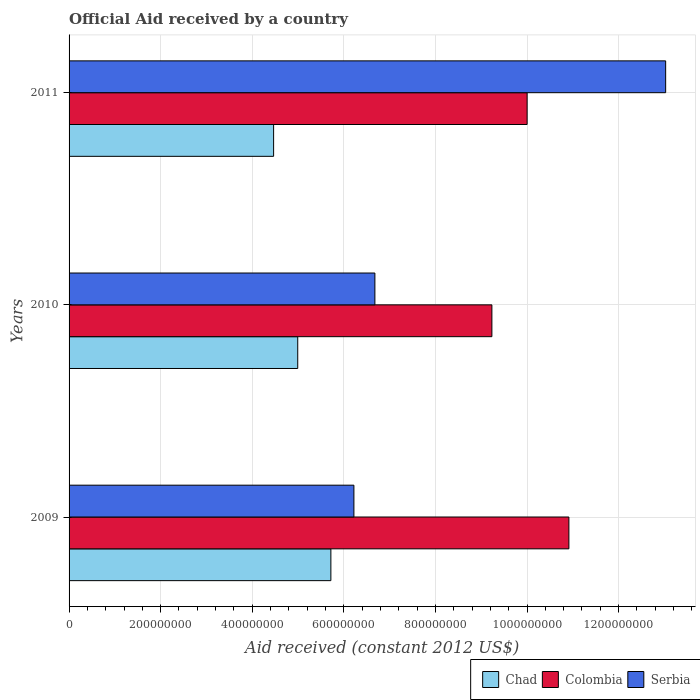How many bars are there on the 2nd tick from the top?
Offer a very short reply. 3. How many bars are there on the 2nd tick from the bottom?
Keep it short and to the point. 3. In how many cases, is the number of bars for a given year not equal to the number of legend labels?
Offer a terse response. 0. What is the net official aid received in Colombia in 2009?
Provide a short and direct response. 1.09e+09. Across all years, what is the maximum net official aid received in Colombia?
Provide a short and direct response. 1.09e+09. Across all years, what is the minimum net official aid received in Serbia?
Provide a short and direct response. 6.22e+08. In which year was the net official aid received in Serbia minimum?
Ensure brevity in your answer.  2009. What is the total net official aid received in Chad in the graph?
Make the answer very short. 1.52e+09. What is the difference between the net official aid received in Chad in 2009 and that in 2011?
Provide a short and direct response. 1.25e+08. What is the difference between the net official aid received in Chad in 2010 and the net official aid received in Serbia in 2009?
Make the answer very short. -1.23e+08. What is the average net official aid received in Colombia per year?
Make the answer very short. 1.01e+09. In the year 2011, what is the difference between the net official aid received in Serbia and net official aid received in Colombia?
Give a very brief answer. 3.03e+08. In how many years, is the net official aid received in Serbia greater than 1080000000 US$?
Keep it short and to the point. 1. What is the ratio of the net official aid received in Serbia in 2009 to that in 2011?
Your answer should be compact. 0.48. Is the net official aid received in Serbia in 2009 less than that in 2010?
Provide a short and direct response. Yes. Is the difference between the net official aid received in Serbia in 2009 and 2011 greater than the difference between the net official aid received in Colombia in 2009 and 2011?
Your answer should be very brief. No. What is the difference between the highest and the second highest net official aid received in Chad?
Ensure brevity in your answer.  7.24e+07. What is the difference between the highest and the lowest net official aid received in Colombia?
Your response must be concise. 1.68e+08. In how many years, is the net official aid received in Chad greater than the average net official aid received in Chad taken over all years?
Provide a short and direct response. 1. What does the 1st bar from the top in 2011 represents?
Your response must be concise. Serbia. What does the 3rd bar from the bottom in 2010 represents?
Make the answer very short. Serbia. How many bars are there?
Ensure brevity in your answer.  9. How many years are there in the graph?
Keep it short and to the point. 3. What is the difference between two consecutive major ticks on the X-axis?
Your response must be concise. 2.00e+08. Are the values on the major ticks of X-axis written in scientific E-notation?
Keep it short and to the point. No. Does the graph contain any zero values?
Offer a terse response. No. Does the graph contain grids?
Ensure brevity in your answer.  Yes. How are the legend labels stacked?
Your answer should be very brief. Horizontal. What is the title of the graph?
Give a very brief answer. Official Aid received by a country. Does "Timor-Leste" appear as one of the legend labels in the graph?
Make the answer very short. No. What is the label or title of the X-axis?
Your answer should be very brief. Aid received (constant 2012 US$). What is the Aid received (constant 2012 US$) in Chad in 2009?
Keep it short and to the point. 5.72e+08. What is the Aid received (constant 2012 US$) in Colombia in 2009?
Offer a terse response. 1.09e+09. What is the Aid received (constant 2012 US$) of Serbia in 2009?
Give a very brief answer. 6.22e+08. What is the Aid received (constant 2012 US$) in Chad in 2010?
Offer a very short reply. 4.99e+08. What is the Aid received (constant 2012 US$) in Colombia in 2010?
Your answer should be compact. 9.23e+08. What is the Aid received (constant 2012 US$) of Serbia in 2010?
Your answer should be very brief. 6.68e+08. What is the Aid received (constant 2012 US$) of Chad in 2011?
Your response must be concise. 4.47e+08. What is the Aid received (constant 2012 US$) of Colombia in 2011?
Your answer should be compact. 1.00e+09. What is the Aid received (constant 2012 US$) in Serbia in 2011?
Provide a short and direct response. 1.30e+09. Across all years, what is the maximum Aid received (constant 2012 US$) in Chad?
Your response must be concise. 5.72e+08. Across all years, what is the maximum Aid received (constant 2012 US$) of Colombia?
Keep it short and to the point. 1.09e+09. Across all years, what is the maximum Aid received (constant 2012 US$) in Serbia?
Offer a very short reply. 1.30e+09. Across all years, what is the minimum Aid received (constant 2012 US$) in Chad?
Give a very brief answer. 4.47e+08. Across all years, what is the minimum Aid received (constant 2012 US$) in Colombia?
Provide a short and direct response. 9.23e+08. Across all years, what is the minimum Aid received (constant 2012 US$) in Serbia?
Ensure brevity in your answer.  6.22e+08. What is the total Aid received (constant 2012 US$) in Chad in the graph?
Offer a very short reply. 1.52e+09. What is the total Aid received (constant 2012 US$) in Colombia in the graph?
Your answer should be compact. 3.02e+09. What is the total Aid received (constant 2012 US$) in Serbia in the graph?
Offer a very short reply. 2.59e+09. What is the difference between the Aid received (constant 2012 US$) of Chad in 2009 and that in 2010?
Give a very brief answer. 7.24e+07. What is the difference between the Aid received (constant 2012 US$) in Colombia in 2009 and that in 2010?
Provide a short and direct response. 1.68e+08. What is the difference between the Aid received (constant 2012 US$) in Serbia in 2009 and that in 2010?
Make the answer very short. -4.58e+07. What is the difference between the Aid received (constant 2012 US$) of Chad in 2009 and that in 2011?
Ensure brevity in your answer.  1.25e+08. What is the difference between the Aid received (constant 2012 US$) of Colombia in 2009 and that in 2011?
Your response must be concise. 9.12e+07. What is the difference between the Aid received (constant 2012 US$) of Serbia in 2009 and that in 2011?
Your response must be concise. -6.81e+08. What is the difference between the Aid received (constant 2012 US$) of Chad in 2010 and that in 2011?
Ensure brevity in your answer.  5.27e+07. What is the difference between the Aid received (constant 2012 US$) in Colombia in 2010 and that in 2011?
Give a very brief answer. -7.69e+07. What is the difference between the Aid received (constant 2012 US$) in Serbia in 2010 and that in 2011?
Give a very brief answer. -6.35e+08. What is the difference between the Aid received (constant 2012 US$) in Chad in 2009 and the Aid received (constant 2012 US$) in Colombia in 2010?
Give a very brief answer. -3.52e+08. What is the difference between the Aid received (constant 2012 US$) in Chad in 2009 and the Aid received (constant 2012 US$) in Serbia in 2010?
Provide a short and direct response. -9.61e+07. What is the difference between the Aid received (constant 2012 US$) in Colombia in 2009 and the Aid received (constant 2012 US$) in Serbia in 2010?
Ensure brevity in your answer.  4.24e+08. What is the difference between the Aid received (constant 2012 US$) in Chad in 2009 and the Aid received (constant 2012 US$) in Colombia in 2011?
Your answer should be compact. -4.29e+08. What is the difference between the Aid received (constant 2012 US$) in Chad in 2009 and the Aid received (constant 2012 US$) in Serbia in 2011?
Ensure brevity in your answer.  -7.31e+08. What is the difference between the Aid received (constant 2012 US$) of Colombia in 2009 and the Aid received (constant 2012 US$) of Serbia in 2011?
Give a very brief answer. -2.11e+08. What is the difference between the Aid received (constant 2012 US$) in Chad in 2010 and the Aid received (constant 2012 US$) in Colombia in 2011?
Offer a very short reply. -5.01e+08. What is the difference between the Aid received (constant 2012 US$) in Chad in 2010 and the Aid received (constant 2012 US$) in Serbia in 2011?
Ensure brevity in your answer.  -8.03e+08. What is the difference between the Aid received (constant 2012 US$) in Colombia in 2010 and the Aid received (constant 2012 US$) in Serbia in 2011?
Keep it short and to the point. -3.79e+08. What is the average Aid received (constant 2012 US$) in Chad per year?
Your answer should be compact. 5.06e+08. What is the average Aid received (constant 2012 US$) in Colombia per year?
Your answer should be very brief. 1.01e+09. What is the average Aid received (constant 2012 US$) of Serbia per year?
Your answer should be very brief. 8.64e+08. In the year 2009, what is the difference between the Aid received (constant 2012 US$) in Chad and Aid received (constant 2012 US$) in Colombia?
Your response must be concise. -5.20e+08. In the year 2009, what is the difference between the Aid received (constant 2012 US$) of Chad and Aid received (constant 2012 US$) of Serbia?
Make the answer very short. -5.03e+07. In the year 2009, what is the difference between the Aid received (constant 2012 US$) of Colombia and Aid received (constant 2012 US$) of Serbia?
Your answer should be very brief. 4.69e+08. In the year 2010, what is the difference between the Aid received (constant 2012 US$) of Chad and Aid received (constant 2012 US$) of Colombia?
Provide a short and direct response. -4.24e+08. In the year 2010, what is the difference between the Aid received (constant 2012 US$) in Chad and Aid received (constant 2012 US$) in Serbia?
Offer a very short reply. -1.68e+08. In the year 2010, what is the difference between the Aid received (constant 2012 US$) of Colombia and Aid received (constant 2012 US$) of Serbia?
Provide a succinct answer. 2.56e+08. In the year 2011, what is the difference between the Aid received (constant 2012 US$) in Chad and Aid received (constant 2012 US$) in Colombia?
Offer a very short reply. -5.54e+08. In the year 2011, what is the difference between the Aid received (constant 2012 US$) of Chad and Aid received (constant 2012 US$) of Serbia?
Your answer should be compact. -8.56e+08. In the year 2011, what is the difference between the Aid received (constant 2012 US$) in Colombia and Aid received (constant 2012 US$) in Serbia?
Ensure brevity in your answer.  -3.03e+08. What is the ratio of the Aid received (constant 2012 US$) of Chad in 2009 to that in 2010?
Provide a succinct answer. 1.14. What is the ratio of the Aid received (constant 2012 US$) in Colombia in 2009 to that in 2010?
Ensure brevity in your answer.  1.18. What is the ratio of the Aid received (constant 2012 US$) of Serbia in 2009 to that in 2010?
Provide a short and direct response. 0.93. What is the ratio of the Aid received (constant 2012 US$) of Chad in 2009 to that in 2011?
Give a very brief answer. 1.28. What is the ratio of the Aid received (constant 2012 US$) of Colombia in 2009 to that in 2011?
Your answer should be compact. 1.09. What is the ratio of the Aid received (constant 2012 US$) of Serbia in 2009 to that in 2011?
Your answer should be very brief. 0.48. What is the ratio of the Aid received (constant 2012 US$) in Chad in 2010 to that in 2011?
Your answer should be very brief. 1.12. What is the ratio of the Aid received (constant 2012 US$) in Serbia in 2010 to that in 2011?
Make the answer very short. 0.51. What is the difference between the highest and the second highest Aid received (constant 2012 US$) of Chad?
Give a very brief answer. 7.24e+07. What is the difference between the highest and the second highest Aid received (constant 2012 US$) of Colombia?
Offer a terse response. 9.12e+07. What is the difference between the highest and the second highest Aid received (constant 2012 US$) in Serbia?
Make the answer very short. 6.35e+08. What is the difference between the highest and the lowest Aid received (constant 2012 US$) of Chad?
Give a very brief answer. 1.25e+08. What is the difference between the highest and the lowest Aid received (constant 2012 US$) of Colombia?
Provide a short and direct response. 1.68e+08. What is the difference between the highest and the lowest Aid received (constant 2012 US$) in Serbia?
Provide a short and direct response. 6.81e+08. 